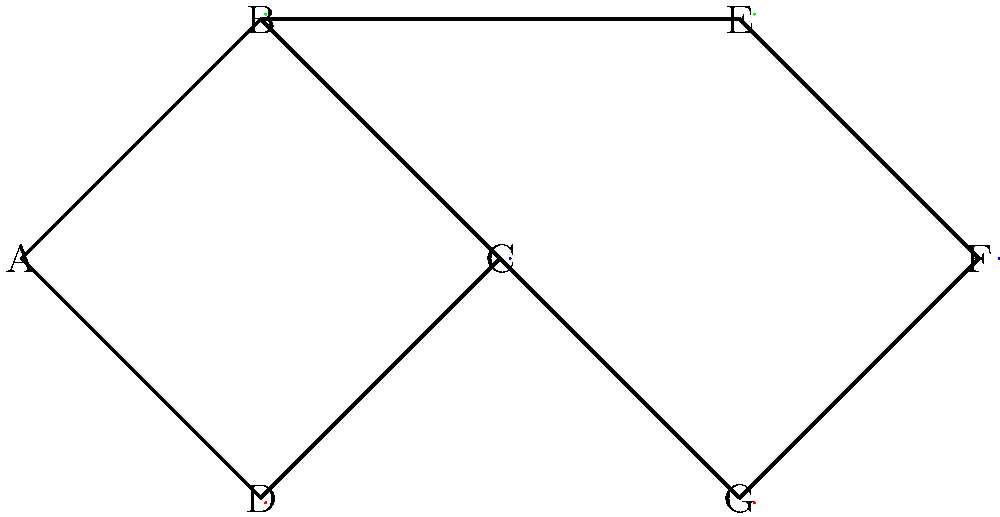In the given social network visualization, which graph coloring algorithm property is demonstrated, and how many colors are used to ensure no adjacent nodes have the same color? To answer this question, we need to analyze the graph coloring in the social network visualization:

1. Observe the coloring of nodes:
   - Nodes A, D, G are colored red
   - Nodes B, E are colored green
   - Nodes C, F are colored blue

2. Check for the graph coloring property:
   - No two adjacent nodes have the same color
   - This demonstrates the proper vertex coloring property

3. Count the number of colors used:
   - Red, Green, and Blue are used
   - Therefore, 3 colors are used in total

4. Verify the optimality:
   - The graph contains a triangle (e.g., A-B-C)
   - A triangle requires at least 3 colors for proper coloring
   - Hence, 3 is the minimum number of colors needed

5. Identify the algorithm property:
   - The coloring achieves proper vertex coloring
   - It uses the minimum number of colors possible
   - This demonstrates the optimal coloring property

Therefore, the graph coloring algorithm demonstrates the optimal coloring property, using 3 colors to ensure no adjacent nodes have the same color.
Answer: Optimal coloring property, 3 colors 